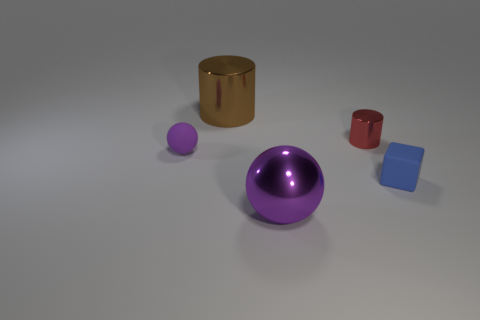Add 4 small gray matte spheres. How many objects exist? 9 Subtract 1 balls. How many balls are left? 1 Subtract 0 gray cylinders. How many objects are left? 5 Subtract all cubes. How many objects are left? 4 Subtract all red cylinders. Subtract all cyan spheres. How many cylinders are left? 1 Subtract all yellow cubes. How many gray cylinders are left? 0 Subtract all tiny red cylinders. Subtract all large purple spheres. How many objects are left? 3 Add 3 large brown cylinders. How many large brown cylinders are left? 4 Add 5 tiny green metallic things. How many tiny green metallic things exist? 5 